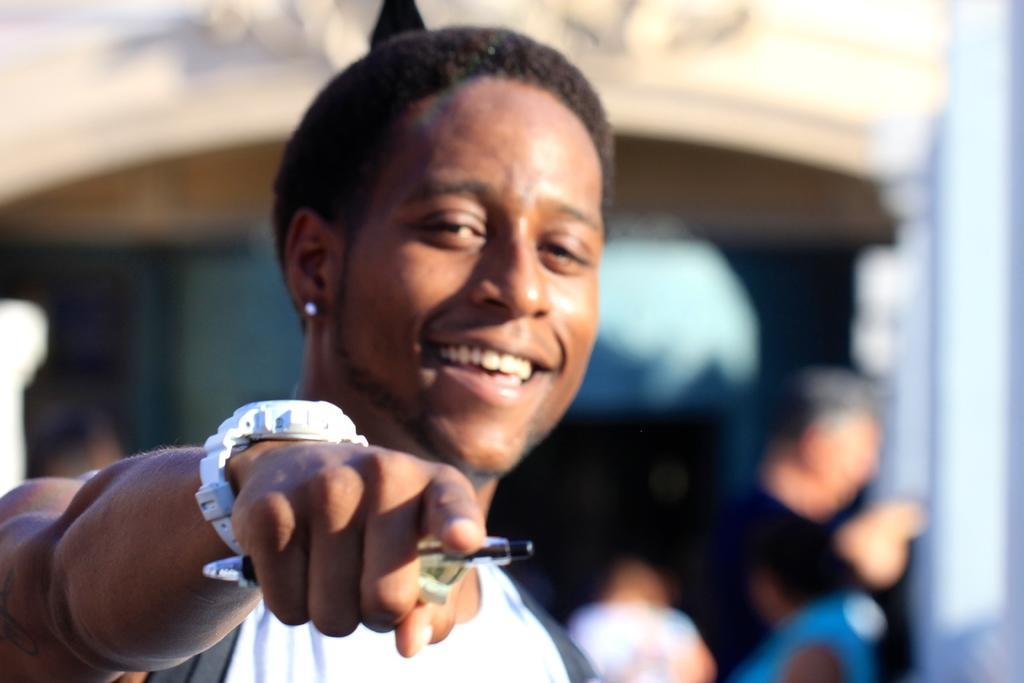Please provide a concise description of this image. In the picture I can see a man. The man is wearing a watch and holding an object in the hand. The background of the image is blurred. 